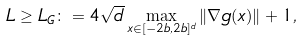<formula> <loc_0><loc_0><loc_500><loc_500>L \geq L _ { G } \colon = 4 \sqrt { d } \max _ { x \in [ - 2 b , 2 b ] ^ { d } } \| \nabla g ( x ) \| + 1 ,</formula> 